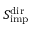<formula> <loc_0><loc_0><loc_500><loc_500>S _ { i m p } ^ { d i r }</formula> 